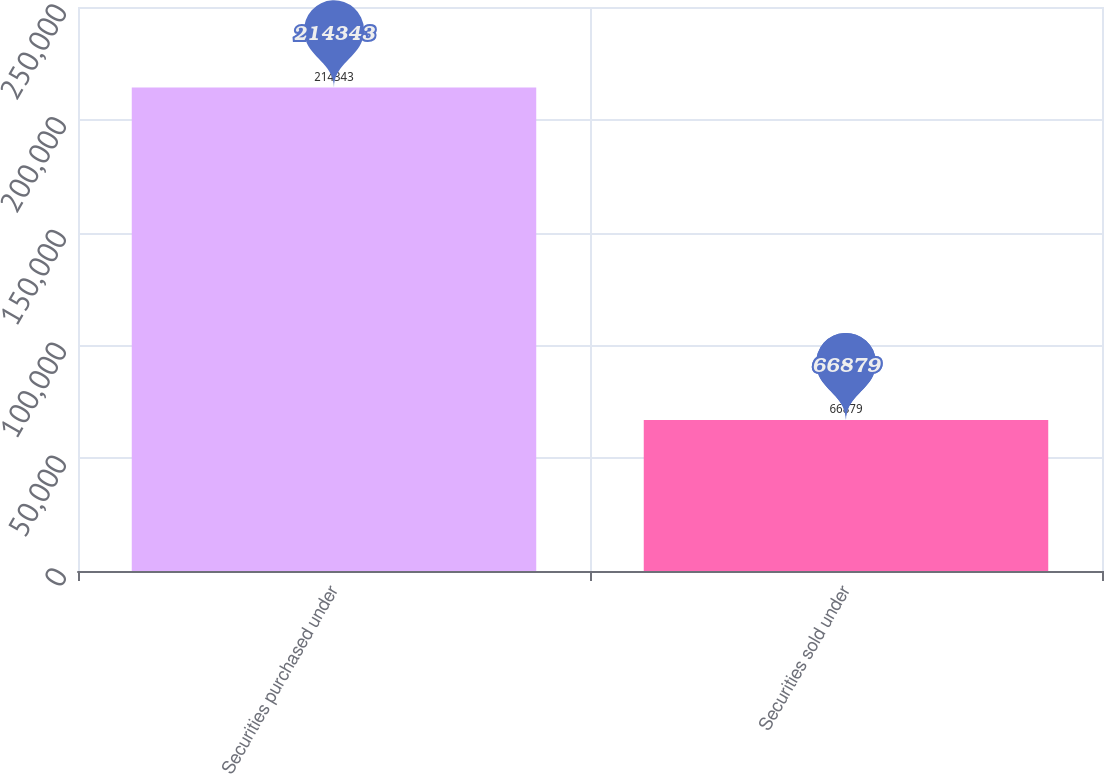<chart> <loc_0><loc_0><loc_500><loc_500><bar_chart><fcel>Securities purchased under<fcel>Securities sold under<nl><fcel>214343<fcel>66879<nl></chart> 